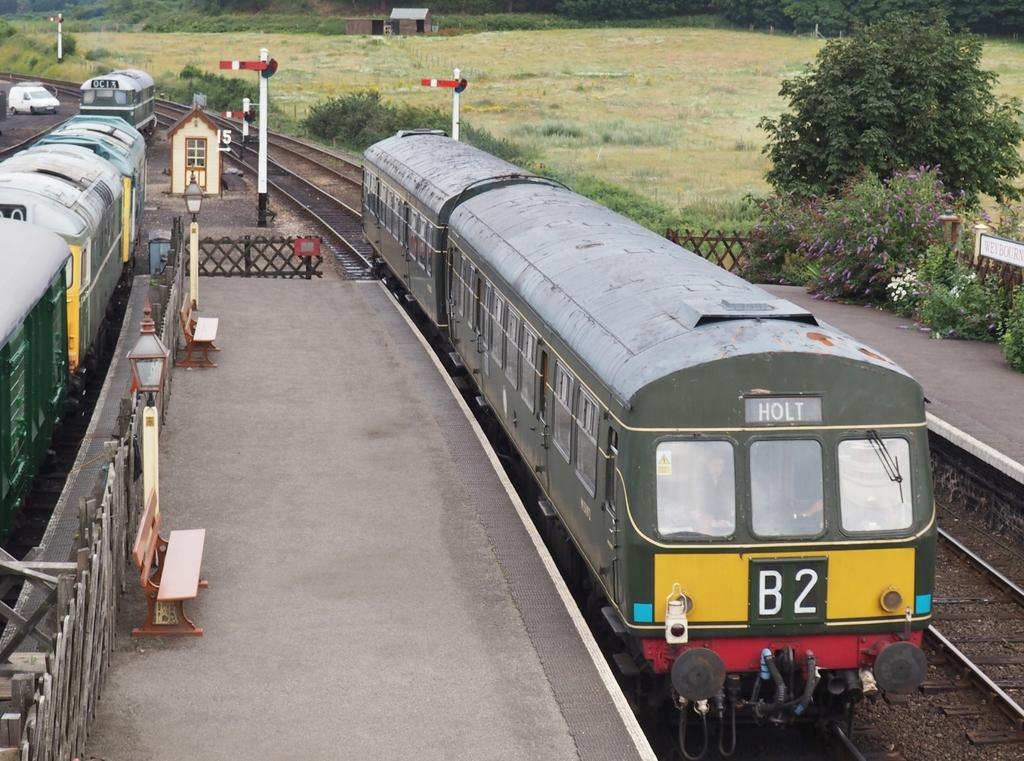<image>
Summarize the visual content of the image. The B2 train is heading to Holt and is painted yellow on the front. 